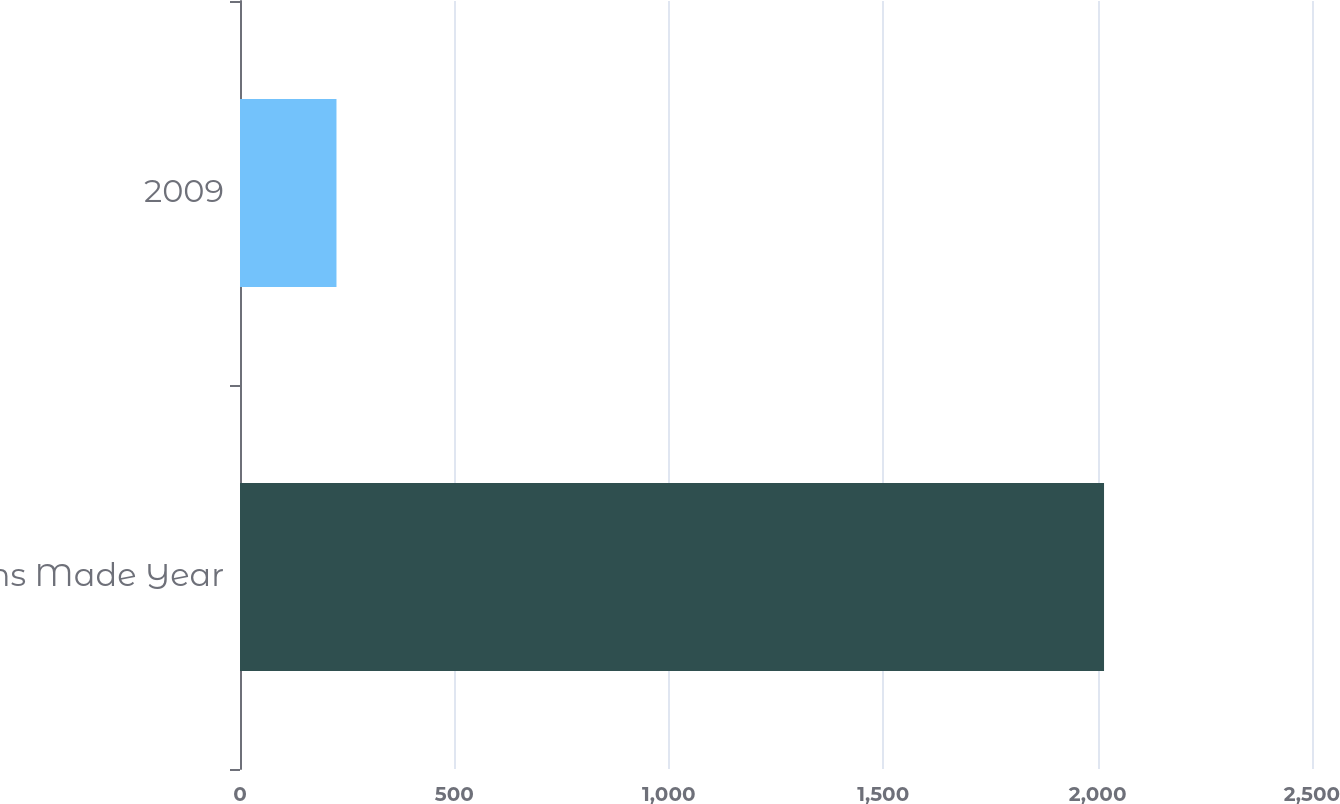<chart> <loc_0><loc_0><loc_500><loc_500><bar_chart><fcel>Claims Made Year<fcel>2009<nl><fcel>2015<fcel>225<nl></chart> 